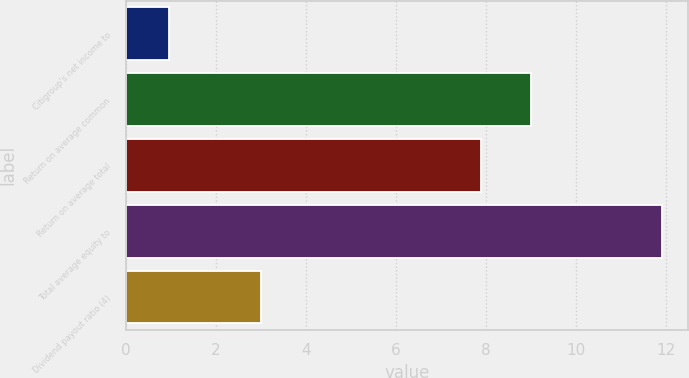Convert chart. <chart><loc_0><loc_0><loc_500><loc_500><bar_chart><fcel>Citigroup's net income to<fcel>Return on average common<fcel>Return on average total<fcel>Total average equity to<fcel>Dividend payout ratio (4)<nl><fcel>0.95<fcel>9<fcel>7.9<fcel>11.9<fcel>3<nl></chart> 